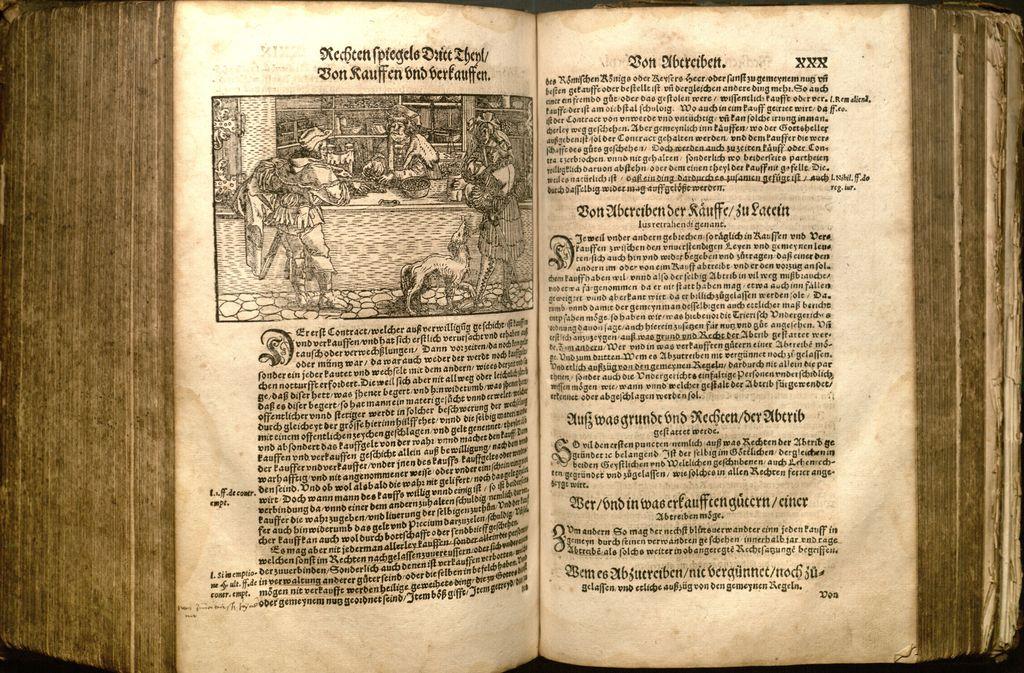What's at the top of the right page?
Your answer should be very brief. Xxx. 